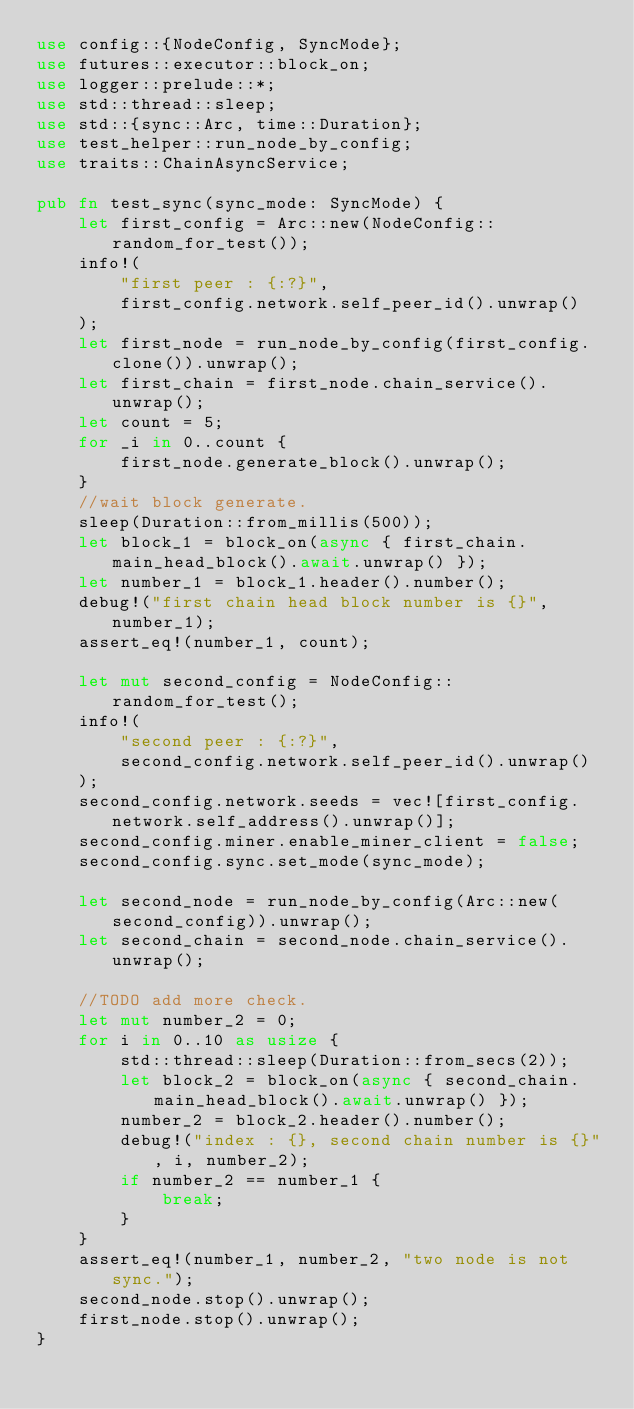Convert code to text. <code><loc_0><loc_0><loc_500><loc_500><_Rust_>use config::{NodeConfig, SyncMode};
use futures::executor::block_on;
use logger::prelude::*;
use std::thread::sleep;
use std::{sync::Arc, time::Duration};
use test_helper::run_node_by_config;
use traits::ChainAsyncService;

pub fn test_sync(sync_mode: SyncMode) {
    let first_config = Arc::new(NodeConfig::random_for_test());
    info!(
        "first peer : {:?}",
        first_config.network.self_peer_id().unwrap()
    );
    let first_node = run_node_by_config(first_config.clone()).unwrap();
    let first_chain = first_node.chain_service().unwrap();
    let count = 5;
    for _i in 0..count {
        first_node.generate_block().unwrap();
    }
    //wait block generate.
    sleep(Duration::from_millis(500));
    let block_1 = block_on(async { first_chain.main_head_block().await.unwrap() });
    let number_1 = block_1.header().number();
    debug!("first chain head block number is {}", number_1);
    assert_eq!(number_1, count);

    let mut second_config = NodeConfig::random_for_test();
    info!(
        "second peer : {:?}",
        second_config.network.self_peer_id().unwrap()
    );
    second_config.network.seeds = vec![first_config.network.self_address().unwrap()];
    second_config.miner.enable_miner_client = false;
    second_config.sync.set_mode(sync_mode);

    let second_node = run_node_by_config(Arc::new(second_config)).unwrap();
    let second_chain = second_node.chain_service().unwrap();

    //TODO add more check.
    let mut number_2 = 0;
    for i in 0..10 as usize {
        std::thread::sleep(Duration::from_secs(2));
        let block_2 = block_on(async { second_chain.main_head_block().await.unwrap() });
        number_2 = block_2.header().number();
        debug!("index : {}, second chain number is {}", i, number_2);
        if number_2 == number_1 {
            break;
        }
    }
    assert_eq!(number_1, number_2, "two node is not sync.");
    second_node.stop().unwrap();
    first_node.stop().unwrap();
}
</code> 